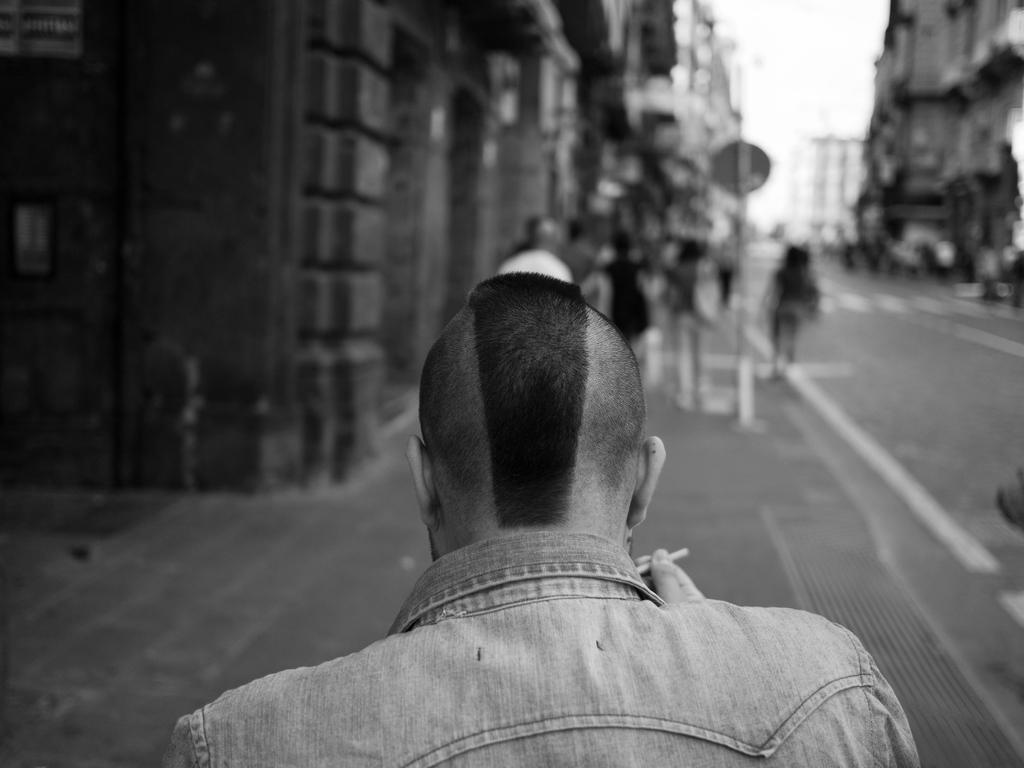What are the people in the image doing? The people in the image are on a path. What else can be seen in the image besides the people? There are buildings and other objects in the image. What is visible in the background of the image? The sky is visible in the image. What type of drain can be seen in the image? There is no drain present in the image. How many buns are visible in the image? There are no buns present in the image. 